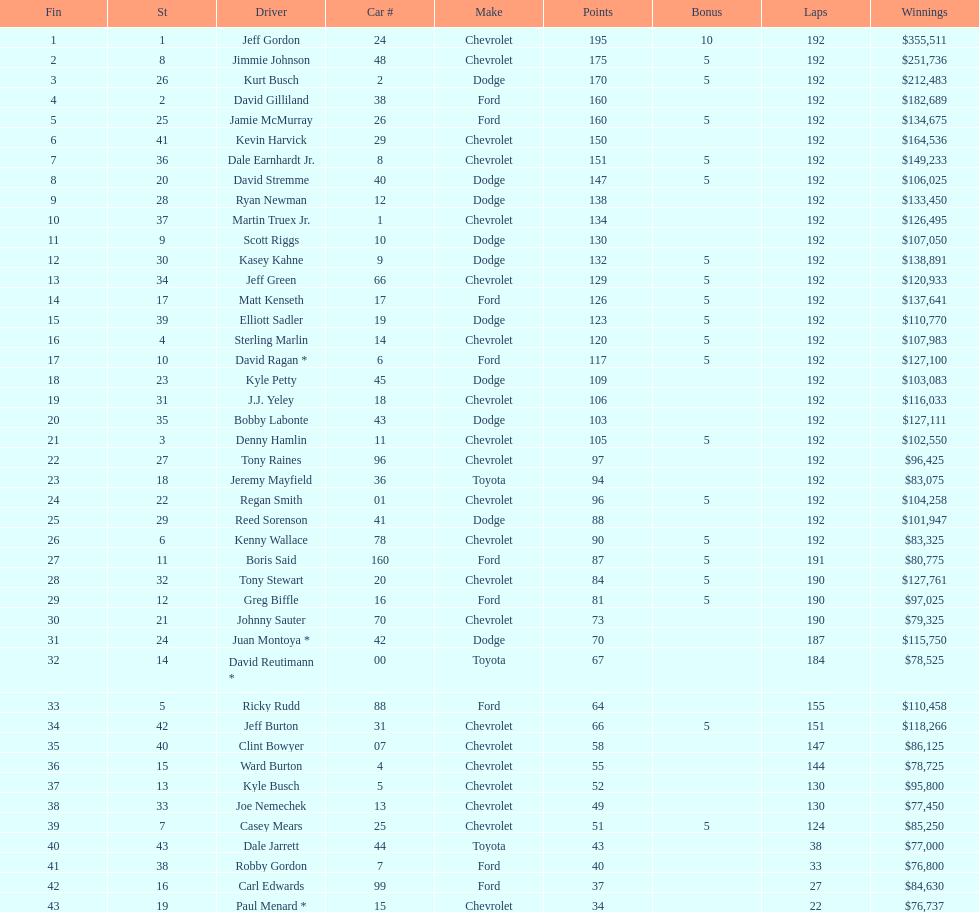How many race car drivers out of the 43 listed drove toyotas? 3. 